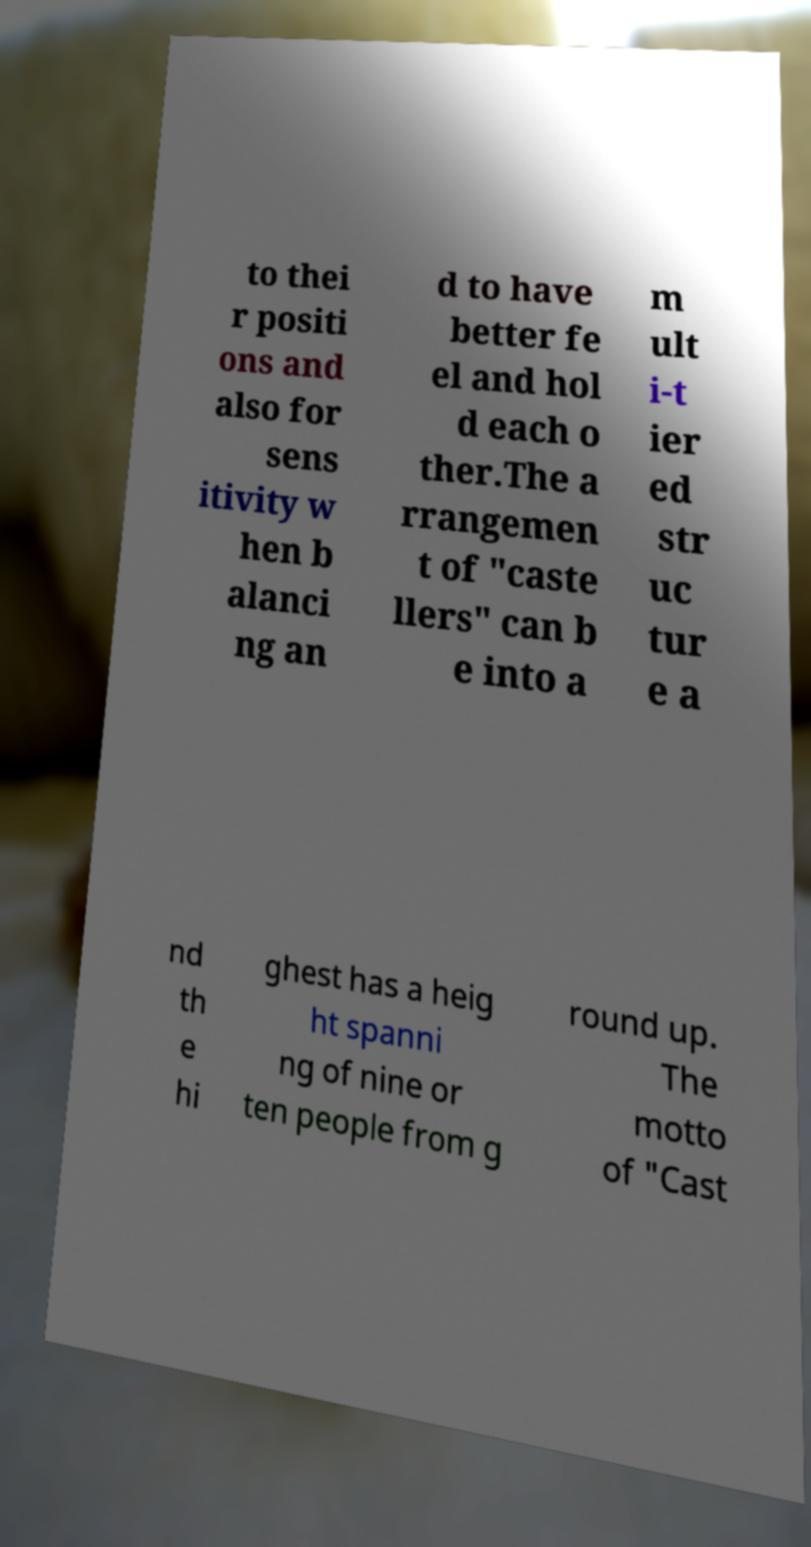Can you accurately transcribe the text from the provided image for me? to thei r positi ons and also for sens itivity w hen b alanci ng an d to have better fe el and hol d each o ther.The a rrangemen t of "caste llers" can b e into a m ult i-t ier ed str uc tur e a nd th e hi ghest has a heig ht spanni ng of nine or ten people from g round up. The motto of "Cast 